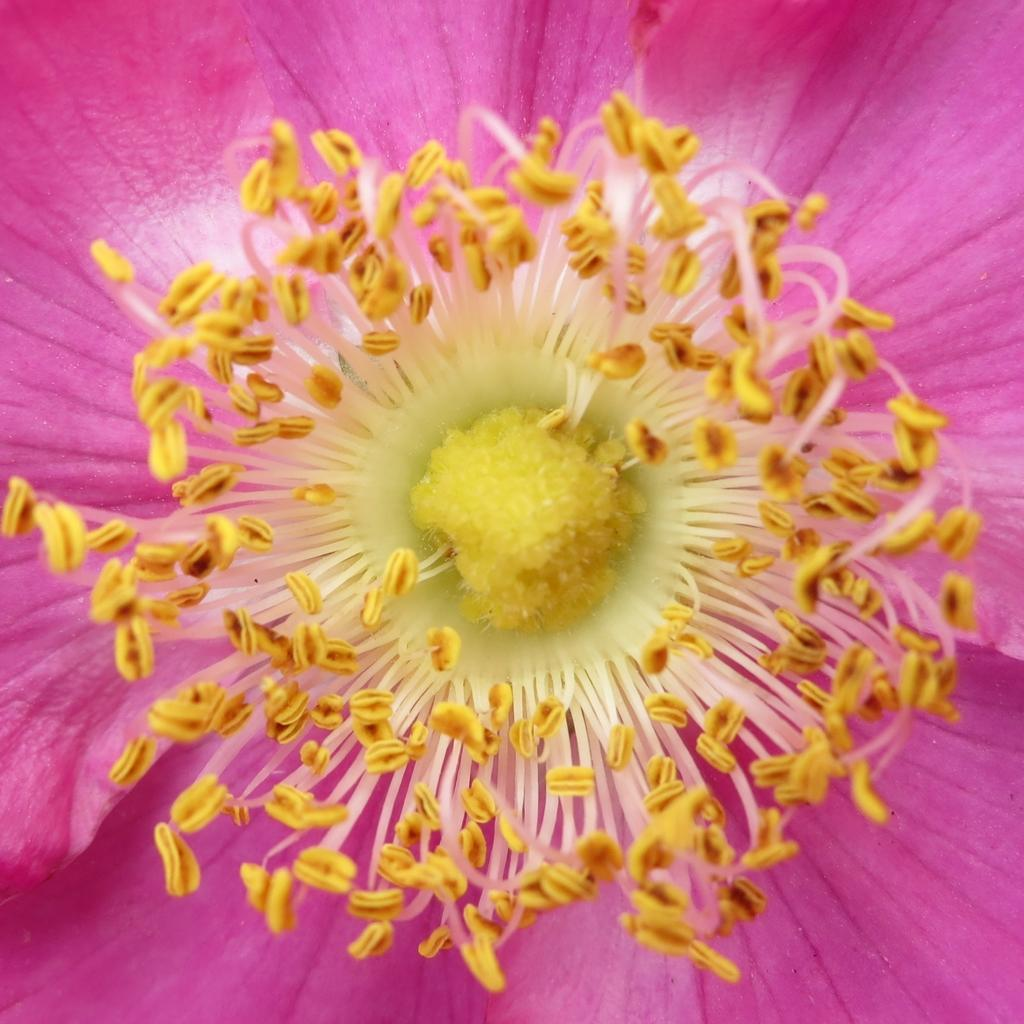What is the main subject of the image? There is a flower in the image. What type of lettuce is being used to knit a scarf in the image? There is no lettuce or knitting activity present in the image; it features a flower. How much money is being exchanged for the flower in the image? There is no indication of a transaction or exchange of money in the image; it simply shows a flower. 